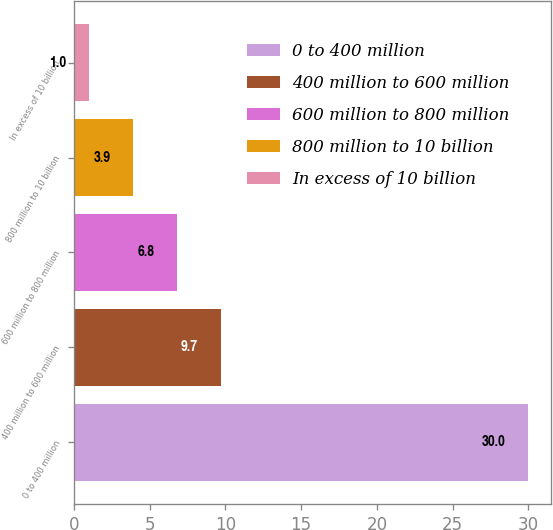Convert chart. <chart><loc_0><loc_0><loc_500><loc_500><bar_chart><fcel>0 to 400 million<fcel>400 million to 600 million<fcel>600 million to 800 million<fcel>800 million to 10 billion<fcel>In excess of 10 billion<nl><fcel>30<fcel>9.7<fcel>6.8<fcel>3.9<fcel>1<nl></chart> 